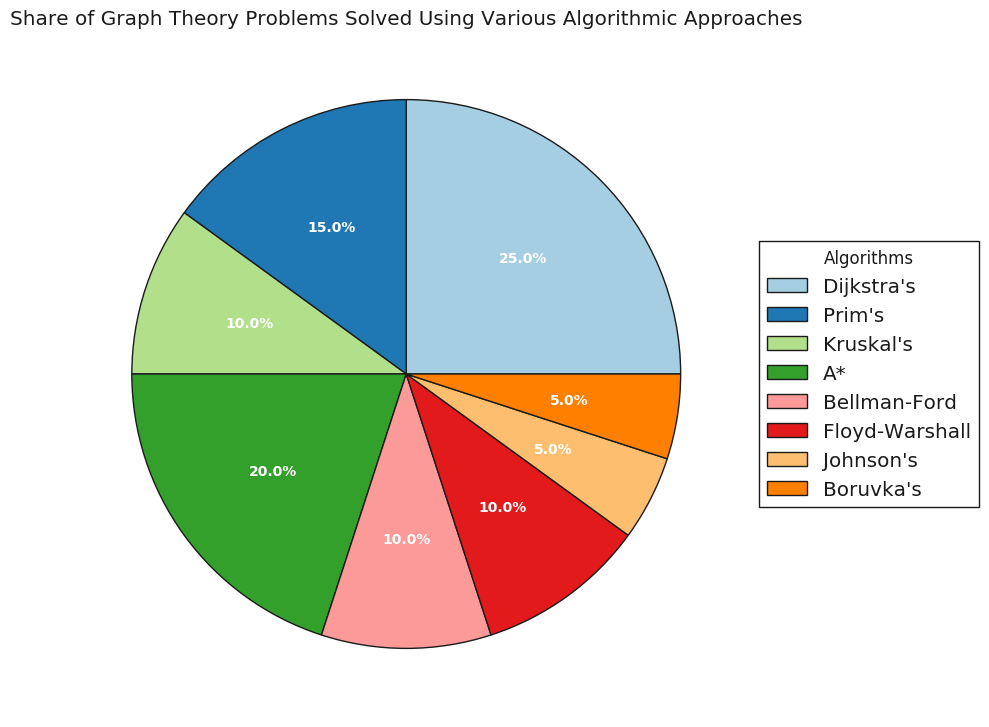What is the share of problems solved using Dijkstra's algorithm? Look at the section titled "Dijkstra's" in the pie chart. The percentage written on this section represents the share of problems solved using Dijkstra's algorithm.
Answer: 25% Which algorithm has the smallest share of problems solved, and what is its percentage? Identify the smallest section in the pie chart. The algorithm name and its percentage are written on or near this section.
Answer: Johnson's and Boruvka's, 5% What is the combined share of problems solved using Bellman-Ford and Floyd-Warshall algorithms? Add the percentages of the sections titled "Bellman-Ford" and "Floyd-Warshall". These sections represent the shares of problems solved using these algorithms.
Answer: 10% + 10% = 20% Which algorithm is used more, A* or Prim's, and by how much? Compare the sections labeled "A*" and "Prim's". The difference between their percentages represents how much more one is used than the other.
Answer: A* by 5% What is the total share of problems solved using minimum spanning tree algorithms (Prim's, Kruskal's, Boruvka's)? Sum up the percentages of the sections labeled "Prim's", "Kruskal's", and "Boruvka's". These sections represent the shares for the minimum spanning tree algorithms.
Answer: 15% + 10% + 5% = 30% Which algorithm has the greatest share of problems solved, and what percentage of the pie chart does it cover? Identify the largest section in the pie chart. The algorithm name and its percentage are written on or near this section.
Answer: Dijkstra's, 25% What is the color of the section representing Johnson's algorithm? Look at the section labeled "Johnson's" and describe its color.
Answer: [Color description based on the chart, e.g., "Light Green"] Is the share of problems solved by Kruskal's algorithm greater than or equal to the share solved by Bellman-Ford? Compare the sections labeled "Kruskal's" and "Bellman-Ford". The percentages written on these sections represent their shares.
Answer: No, both are 10% How many algorithms have a share of 10%? Count the number of sections in the pie chart that label a share of 10%.
Answer: 3 What percentage of problems are solved by the two most common algorithms combined? Identify the two largest sections in the pie chart and sum their percentages. These sections represent the shares of the two most common algorithms.
Answer: 25% + 20% = 45% 